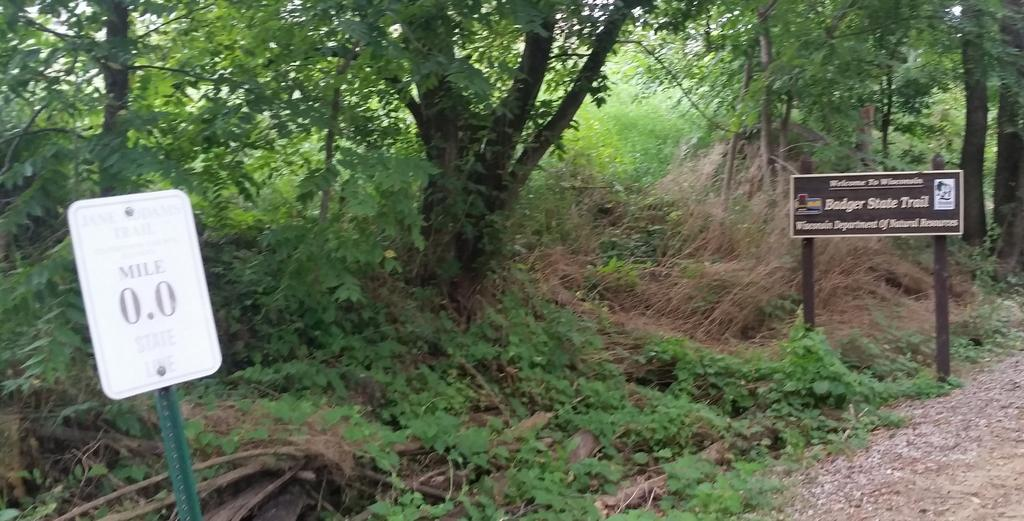What type of vegetation can be seen in the image? There are trees and plants in the image. What is the condition of the grass in the image? Dry grass is present in the image. What is the purpose of the sign board in the image? The purpose of the sign board in the image is not clear from the facts provided. How are the poster and poles arranged in the image? There is a poster with poles in the image. What is visible on the ground in the image? The ground is visible in the image, and there are stones on the ground. Can you see the baby's fang in the image? There is no baby or fang present in the image. What is the edge of the image made of? The edge of the image is not visible in the image itself, as it is a physical property of the photograph or digital file. 